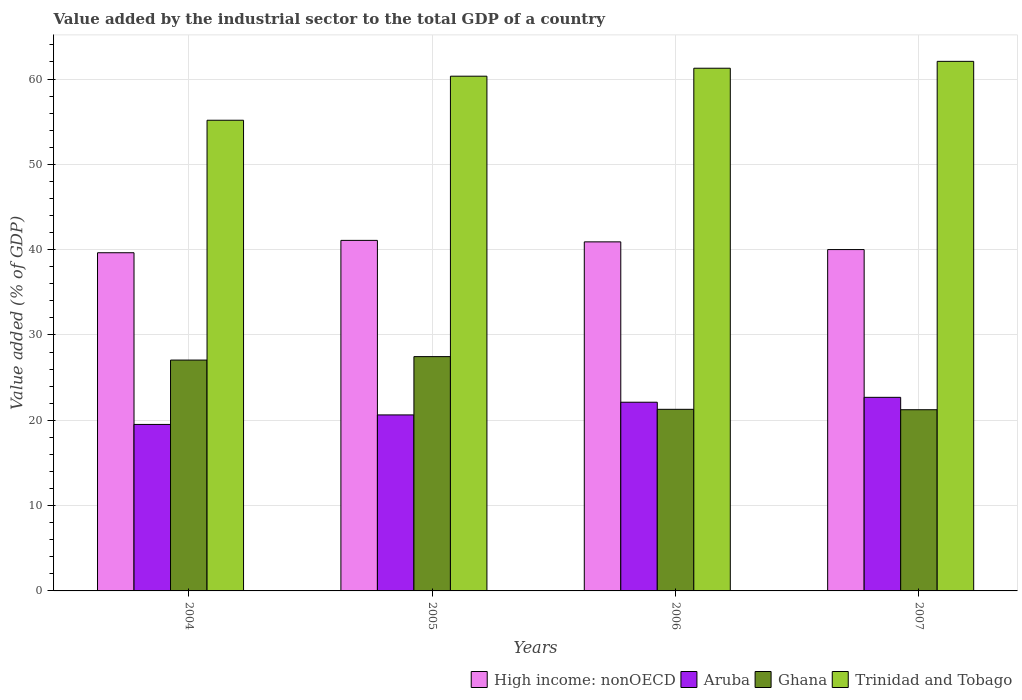How many different coloured bars are there?
Your response must be concise. 4. How many groups of bars are there?
Keep it short and to the point. 4. Are the number of bars on each tick of the X-axis equal?
Give a very brief answer. Yes. How many bars are there on the 3rd tick from the right?
Your answer should be compact. 4. In how many cases, is the number of bars for a given year not equal to the number of legend labels?
Your answer should be very brief. 0. What is the value added by the industrial sector to the total GDP in High income: nonOECD in 2005?
Provide a short and direct response. 41.09. Across all years, what is the maximum value added by the industrial sector to the total GDP in High income: nonOECD?
Keep it short and to the point. 41.09. Across all years, what is the minimum value added by the industrial sector to the total GDP in Trinidad and Tobago?
Provide a succinct answer. 55.17. In which year was the value added by the industrial sector to the total GDP in Aruba maximum?
Provide a short and direct response. 2007. What is the total value added by the industrial sector to the total GDP in Aruba in the graph?
Keep it short and to the point. 84.95. What is the difference between the value added by the industrial sector to the total GDP in Aruba in 2005 and that in 2007?
Provide a short and direct response. -2.06. What is the difference between the value added by the industrial sector to the total GDP in Trinidad and Tobago in 2005 and the value added by the industrial sector to the total GDP in Aruba in 2004?
Ensure brevity in your answer.  40.82. What is the average value added by the industrial sector to the total GDP in Trinidad and Tobago per year?
Ensure brevity in your answer.  59.71. In the year 2005, what is the difference between the value added by the industrial sector to the total GDP in Trinidad and Tobago and value added by the industrial sector to the total GDP in Ghana?
Your response must be concise. 32.87. What is the ratio of the value added by the industrial sector to the total GDP in High income: nonOECD in 2005 to that in 2007?
Keep it short and to the point. 1.03. Is the difference between the value added by the industrial sector to the total GDP in Trinidad and Tobago in 2006 and 2007 greater than the difference between the value added by the industrial sector to the total GDP in Ghana in 2006 and 2007?
Provide a succinct answer. No. What is the difference between the highest and the second highest value added by the industrial sector to the total GDP in Aruba?
Your response must be concise. 0.57. What is the difference between the highest and the lowest value added by the industrial sector to the total GDP in Aruba?
Give a very brief answer. 3.18. Is the sum of the value added by the industrial sector to the total GDP in Trinidad and Tobago in 2004 and 2006 greater than the maximum value added by the industrial sector to the total GDP in Ghana across all years?
Provide a succinct answer. Yes. Is it the case that in every year, the sum of the value added by the industrial sector to the total GDP in High income: nonOECD and value added by the industrial sector to the total GDP in Trinidad and Tobago is greater than the sum of value added by the industrial sector to the total GDP in Aruba and value added by the industrial sector to the total GDP in Ghana?
Give a very brief answer. Yes. What does the 4th bar from the left in 2004 represents?
Make the answer very short. Trinidad and Tobago. What does the 4th bar from the right in 2007 represents?
Your answer should be very brief. High income: nonOECD. Are all the bars in the graph horizontal?
Your answer should be very brief. No. What is the difference between two consecutive major ticks on the Y-axis?
Your answer should be very brief. 10. Does the graph contain grids?
Provide a succinct answer. Yes. Where does the legend appear in the graph?
Provide a short and direct response. Bottom right. What is the title of the graph?
Provide a short and direct response. Value added by the industrial sector to the total GDP of a country. Does "Fiji" appear as one of the legend labels in the graph?
Keep it short and to the point. No. What is the label or title of the X-axis?
Give a very brief answer. Years. What is the label or title of the Y-axis?
Your answer should be very brief. Value added (% of GDP). What is the Value added (% of GDP) of High income: nonOECD in 2004?
Your answer should be very brief. 39.64. What is the Value added (% of GDP) in Aruba in 2004?
Offer a very short reply. 19.51. What is the Value added (% of GDP) of Ghana in 2004?
Ensure brevity in your answer.  27.06. What is the Value added (% of GDP) of Trinidad and Tobago in 2004?
Your response must be concise. 55.17. What is the Value added (% of GDP) in High income: nonOECD in 2005?
Ensure brevity in your answer.  41.09. What is the Value added (% of GDP) of Aruba in 2005?
Your answer should be very brief. 20.63. What is the Value added (% of GDP) in Ghana in 2005?
Provide a short and direct response. 27.46. What is the Value added (% of GDP) of Trinidad and Tobago in 2005?
Provide a succinct answer. 60.33. What is the Value added (% of GDP) of High income: nonOECD in 2006?
Provide a short and direct response. 40.91. What is the Value added (% of GDP) of Aruba in 2006?
Provide a short and direct response. 22.12. What is the Value added (% of GDP) of Ghana in 2006?
Offer a very short reply. 21.29. What is the Value added (% of GDP) in Trinidad and Tobago in 2006?
Your answer should be compact. 61.26. What is the Value added (% of GDP) in High income: nonOECD in 2007?
Provide a succinct answer. 40.01. What is the Value added (% of GDP) in Aruba in 2007?
Offer a terse response. 22.69. What is the Value added (% of GDP) in Ghana in 2007?
Your answer should be very brief. 21.24. What is the Value added (% of GDP) of Trinidad and Tobago in 2007?
Offer a very short reply. 62.07. Across all years, what is the maximum Value added (% of GDP) in High income: nonOECD?
Your response must be concise. 41.09. Across all years, what is the maximum Value added (% of GDP) of Aruba?
Your response must be concise. 22.69. Across all years, what is the maximum Value added (% of GDP) in Ghana?
Offer a terse response. 27.46. Across all years, what is the maximum Value added (% of GDP) of Trinidad and Tobago?
Provide a succinct answer. 62.07. Across all years, what is the minimum Value added (% of GDP) of High income: nonOECD?
Give a very brief answer. 39.64. Across all years, what is the minimum Value added (% of GDP) of Aruba?
Give a very brief answer. 19.51. Across all years, what is the minimum Value added (% of GDP) in Ghana?
Your response must be concise. 21.24. Across all years, what is the minimum Value added (% of GDP) of Trinidad and Tobago?
Offer a terse response. 55.17. What is the total Value added (% of GDP) of High income: nonOECD in the graph?
Keep it short and to the point. 161.64. What is the total Value added (% of GDP) of Aruba in the graph?
Give a very brief answer. 84.95. What is the total Value added (% of GDP) in Ghana in the graph?
Give a very brief answer. 97.04. What is the total Value added (% of GDP) of Trinidad and Tobago in the graph?
Provide a succinct answer. 238.83. What is the difference between the Value added (% of GDP) of High income: nonOECD in 2004 and that in 2005?
Offer a terse response. -1.45. What is the difference between the Value added (% of GDP) of Aruba in 2004 and that in 2005?
Your response must be concise. -1.12. What is the difference between the Value added (% of GDP) in Ghana in 2004 and that in 2005?
Ensure brevity in your answer.  -0.4. What is the difference between the Value added (% of GDP) of Trinidad and Tobago in 2004 and that in 2005?
Make the answer very short. -5.16. What is the difference between the Value added (% of GDP) of High income: nonOECD in 2004 and that in 2006?
Keep it short and to the point. -1.27. What is the difference between the Value added (% of GDP) of Aruba in 2004 and that in 2006?
Provide a short and direct response. -2.6. What is the difference between the Value added (% of GDP) of Ghana in 2004 and that in 2006?
Give a very brief answer. 5.77. What is the difference between the Value added (% of GDP) in Trinidad and Tobago in 2004 and that in 2006?
Ensure brevity in your answer.  -6.1. What is the difference between the Value added (% of GDP) of High income: nonOECD in 2004 and that in 2007?
Your response must be concise. -0.37. What is the difference between the Value added (% of GDP) of Aruba in 2004 and that in 2007?
Provide a succinct answer. -3.18. What is the difference between the Value added (% of GDP) in Ghana in 2004 and that in 2007?
Your answer should be very brief. 5.82. What is the difference between the Value added (% of GDP) of Trinidad and Tobago in 2004 and that in 2007?
Provide a succinct answer. -6.9. What is the difference between the Value added (% of GDP) in High income: nonOECD in 2005 and that in 2006?
Provide a succinct answer. 0.17. What is the difference between the Value added (% of GDP) in Aruba in 2005 and that in 2006?
Keep it short and to the point. -1.49. What is the difference between the Value added (% of GDP) in Ghana in 2005 and that in 2006?
Make the answer very short. 6.18. What is the difference between the Value added (% of GDP) of Trinidad and Tobago in 2005 and that in 2006?
Your answer should be very brief. -0.93. What is the difference between the Value added (% of GDP) in High income: nonOECD in 2005 and that in 2007?
Your response must be concise. 1.08. What is the difference between the Value added (% of GDP) of Aruba in 2005 and that in 2007?
Keep it short and to the point. -2.06. What is the difference between the Value added (% of GDP) in Ghana in 2005 and that in 2007?
Provide a succinct answer. 6.22. What is the difference between the Value added (% of GDP) of Trinidad and Tobago in 2005 and that in 2007?
Provide a short and direct response. -1.74. What is the difference between the Value added (% of GDP) in High income: nonOECD in 2006 and that in 2007?
Give a very brief answer. 0.9. What is the difference between the Value added (% of GDP) in Aruba in 2006 and that in 2007?
Provide a succinct answer. -0.57. What is the difference between the Value added (% of GDP) in Ghana in 2006 and that in 2007?
Your response must be concise. 0.05. What is the difference between the Value added (% of GDP) of Trinidad and Tobago in 2006 and that in 2007?
Your answer should be compact. -0.81. What is the difference between the Value added (% of GDP) in High income: nonOECD in 2004 and the Value added (% of GDP) in Aruba in 2005?
Provide a short and direct response. 19.01. What is the difference between the Value added (% of GDP) of High income: nonOECD in 2004 and the Value added (% of GDP) of Ghana in 2005?
Provide a succinct answer. 12.18. What is the difference between the Value added (% of GDP) of High income: nonOECD in 2004 and the Value added (% of GDP) of Trinidad and Tobago in 2005?
Your answer should be very brief. -20.69. What is the difference between the Value added (% of GDP) in Aruba in 2004 and the Value added (% of GDP) in Ghana in 2005?
Keep it short and to the point. -7.95. What is the difference between the Value added (% of GDP) of Aruba in 2004 and the Value added (% of GDP) of Trinidad and Tobago in 2005?
Ensure brevity in your answer.  -40.82. What is the difference between the Value added (% of GDP) in Ghana in 2004 and the Value added (% of GDP) in Trinidad and Tobago in 2005?
Your answer should be compact. -33.27. What is the difference between the Value added (% of GDP) in High income: nonOECD in 2004 and the Value added (% of GDP) in Aruba in 2006?
Your answer should be compact. 17.52. What is the difference between the Value added (% of GDP) in High income: nonOECD in 2004 and the Value added (% of GDP) in Ghana in 2006?
Provide a succinct answer. 18.35. What is the difference between the Value added (% of GDP) of High income: nonOECD in 2004 and the Value added (% of GDP) of Trinidad and Tobago in 2006?
Keep it short and to the point. -21.63. What is the difference between the Value added (% of GDP) in Aruba in 2004 and the Value added (% of GDP) in Ghana in 2006?
Provide a succinct answer. -1.77. What is the difference between the Value added (% of GDP) in Aruba in 2004 and the Value added (% of GDP) in Trinidad and Tobago in 2006?
Ensure brevity in your answer.  -41.75. What is the difference between the Value added (% of GDP) in Ghana in 2004 and the Value added (% of GDP) in Trinidad and Tobago in 2006?
Your answer should be very brief. -34.21. What is the difference between the Value added (% of GDP) of High income: nonOECD in 2004 and the Value added (% of GDP) of Aruba in 2007?
Make the answer very short. 16.95. What is the difference between the Value added (% of GDP) in High income: nonOECD in 2004 and the Value added (% of GDP) in Ghana in 2007?
Your answer should be compact. 18.4. What is the difference between the Value added (% of GDP) of High income: nonOECD in 2004 and the Value added (% of GDP) of Trinidad and Tobago in 2007?
Your answer should be compact. -22.43. What is the difference between the Value added (% of GDP) of Aruba in 2004 and the Value added (% of GDP) of Ghana in 2007?
Your answer should be very brief. -1.72. What is the difference between the Value added (% of GDP) of Aruba in 2004 and the Value added (% of GDP) of Trinidad and Tobago in 2007?
Offer a very short reply. -42.56. What is the difference between the Value added (% of GDP) in Ghana in 2004 and the Value added (% of GDP) in Trinidad and Tobago in 2007?
Your response must be concise. -35.01. What is the difference between the Value added (% of GDP) in High income: nonOECD in 2005 and the Value added (% of GDP) in Aruba in 2006?
Your answer should be compact. 18.97. What is the difference between the Value added (% of GDP) in High income: nonOECD in 2005 and the Value added (% of GDP) in Ghana in 2006?
Ensure brevity in your answer.  19.8. What is the difference between the Value added (% of GDP) in High income: nonOECD in 2005 and the Value added (% of GDP) in Trinidad and Tobago in 2006?
Your answer should be very brief. -20.18. What is the difference between the Value added (% of GDP) in Aruba in 2005 and the Value added (% of GDP) in Ghana in 2006?
Your answer should be compact. -0.66. What is the difference between the Value added (% of GDP) in Aruba in 2005 and the Value added (% of GDP) in Trinidad and Tobago in 2006?
Your answer should be compact. -40.63. What is the difference between the Value added (% of GDP) in Ghana in 2005 and the Value added (% of GDP) in Trinidad and Tobago in 2006?
Your answer should be very brief. -33.8. What is the difference between the Value added (% of GDP) of High income: nonOECD in 2005 and the Value added (% of GDP) of Aruba in 2007?
Your answer should be very brief. 18.4. What is the difference between the Value added (% of GDP) in High income: nonOECD in 2005 and the Value added (% of GDP) in Ghana in 2007?
Offer a terse response. 19.85. What is the difference between the Value added (% of GDP) in High income: nonOECD in 2005 and the Value added (% of GDP) in Trinidad and Tobago in 2007?
Provide a succinct answer. -20.98. What is the difference between the Value added (% of GDP) of Aruba in 2005 and the Value added (% of GDP) of Ghana in 2007?
Give a very brief answer. -0.61. What is the difference between the Value added (% of GDP) in Aruba in 2005 and the Value added (% of GDP) in Trinidad and Tobago in 2007?
Provide a short and direct response. -41.44. What is the difference between the Value added (% of GDP) in Ghana in 2005 and the Value added (% of GDP) in Trinidad and Tobago in 2007?
Offer a terse response. -34.61. What is the difference between the Value added (% of GDP) in High income: nonOECD in 2006 and the Value added (% of GDP) in Aruba in 2007?
Ensure brevity in your answer.  18.22. What is the difference between the Value added (% of GDP) of High income: nonOECD in 2006 and the Value added (% of GDP) of Ghana in 2007?
Make the answer very short. 19.67. What is the difference between the Value added (% of GDP) of High income: nonOECD in 2006 and the Value added (% of GDP) of Trinidad and Tobago in 2007?
Offer a very short reply. -21.16. What is the difference between the Value added (% of GDP) of Aruba in 2006 and the Value added (% of GDP) of Ghana in 2007?
Your answer should be very brief. 0.88. What is the difference between the Value added (% of GDP) in Aruba in 2006 and the Value added (% of GDP) in Trinidad and Tobago in 2007?
Your answer should be compact. -39.95. What is the difference between the Value added (% of GDP) of Ghana in 2006 and the Value added (% of GDP) of Trinidad and Tobago in 2007?
Offer a very short reply. -40.78. What is the average Value added (% of GDP) of High income: nonOECD per year?
Keep it short and to the point. 40.41. What is the average Value added (% of GDP) of Aruba per year?
Keep it short and to the point. 21.24. What is the average Value added (% of GDP) in Ghana per year?
Offer a terse response. 24.26. What is the average Value added (% of GDP) of Trinidad and Tobago per year?
Make the answer very short. 59.71. In the year 2004, what is the difference between the Value added (% of GDP) in High income: nonOECD and Value added (% of GDP) in Aruba?
Offer a terse response. 20.12. In the year 2004, what is the difference between the Value added (% of GDP) in High income: nonOECD and Value added (% of GDP) in Ghana?
Your answer should be very brief. 12.58. In the year 2004, what is the difference between the Value added (% of GDP) of High income: nonOECD and Value added (% of GDP) of Trinidad and Tobago?
Offer a terse response. -15.53. In the year 2004, what is the difference between the Value added (% of GDP) in Aruba and Value added (% of GDP) in Ghana?
Offer a terse response. -7.54. In the year 2004, what is the difference between the Value added (% of GDP) of Aruba and Value added (% of GDP) of Trinidad and Tobago?
Offer a very short reply. -35.65. In the year 2004, what is the difference between the Value added (% of GDP) in Ghana and Value added (% of GDP) in Trinidad and Tobago?
Offer a very short reply. -28.11. In the year 2005, what is the difference between the Value added (% of GDP) of High income: nonOECD and Value added (% of GDP) of Aruba?
Ensure brevity in your answer.  20.46. In the year 2005, what is the difference between the Value added (% of GDP) in High income: nonOECD and Value added (% of GDP) in Ghana?
Your answer should be very brief. 13.62. In the year 2005, what is the difference between the Value added (% of GDP) of High income: nonOECD and Value added (% of GDP) of Trinidad and Tobago?
Your answer should be compact. -19.24. In the year 2005, what is the difference between the Value added (% of GDP) in Aruba and Value added (% of GDP) in Ghana?
Keep it short and to the point. -6.83. In the year 2005, what is the difference between the Value added (% of GDP) in Aruba and Value added (% of GDP) in Trinidad and Tobago?
Keep it short and to the point. -39.7. In the year 2005, what is the difference between the Value added (% of GDP) in Ghana and Value added (% of GDP) in Trinidad and Tobago?
Ensure brevity in your answer.  -32.87. In the year 2006, what is the difference between the Value added (% of GDP) in High income: nonOECD and Value added (% of GDP) in Aruba?
Offer a terse response. 18.8. In the year 2006, what is the difference between the Value added (% of GDP) of High income: nonOECD and Value added (% of GDP) of Ghana?
Your response must be concise. 19.63. In the year 2006, what is the difference between the Value added (% of GDP) in High income: nonOECD and Value added (% of GDP) in Trinidad and Tobago?
Give a very brief answer. -20.35. In the year 2006, what is the difference between the Value added (% of GDP) of Aruba and Value added (% of GDP) of Ghana?
Your response must be concise. 0.83. In the year 2006, what is the difference between the Value added (% of GDP) of Aruba and Value added (% of GDP) of Trinidad and Tobago?
Keep it short and to the point. -39.15. In the year 2006, what is the difference between the Value added (% of GDP) in Ghana and Value added (% of GDP) in Trinidad and Tobago?
Your answer should be very brief. -39.98. In the year 2007, what is the difference between the Value added (% of GDP) of High income: nonOECD and Value added (% of GDP) of Aruba?
Your answer should be compact. 17.32. In the year 2007, what is the difference between the Value added (% of GDP) of High income: nonOECD and Value added (% of GDP) of Ghana?
Your response must be concise. 18.77. In the year 2007, what is the difference between the Value added (% of GDP) in High income: nonOECD and Value added (% of GDP) in Trinidad and Tobago?
Your answer should be very brief. -22.06. In the year 2007, what is the difference between the Value added (% of GDP) in Aruba and Value added (% of GDP) in Ghana?
Give a very brief answer. 1.45. In the year 2007, what is the difference between the Value added (% of GDP) in Aruba and Value added (% of GDP) in Trinidad and Tobago?
Provide a succinct answer. -39.38. In the year 2007, what is the difference between the Value added (% of GDP) of Ghana and Value added (% of GDP) of Trinidad and Tobago?
Ensure brevity in your answer.  -40.83. What is the ratio of the Value added (% of GDP) in High income: nonOECD in 2004 to that in 2005?
Ensure brevity in your answer.  0.96. What is the ratio of the Value added (% of GDP) in Aruba in 2004 to that in 2005?
Offer a terse response. 0.95. What is the ratio of the Value added (% of GDP) of Trinidad and Tobago in 2004 to that in 2005?
Provide a succinct answer. 0.91. What is the ratio of the Value added (% of GDP) of High income: nonOECD in 2004 to that in 2006?
Offer a terse response. 0.97. What is the ratio of the Value added (% of GDP) in Aruba in 2004 to that in 2006?
Your answer should be very brief. 0.88. What is the ratio of the Value added (% of GDP) in Ghana in 2004 to that in 2006?
Provide a short and direct response. 1.27. What is the ratio of the Value added (% of GDP) of Trinidad and Tobago in 2004 to that in 2006?
Give a very brief answer. 0.9. What is the ratio of the Value added (% of GDP) of Aruba in 2004 to that in 2007?
Offer a very short reply. 0.86. What is the ratio of the Value added (% of GDP) of Ghana in 2004 to that in 2007?
Provide a succinct answer. 1.27. What is the ratio of the Value added (% of GDP) of Trinidad and Tobago in 2004 to that in 2007?
Your answer should be very brief. 0.89. What is the ratio of the Value added (% of GDP) in High income: nonOECD in 2005 to that in 2006?
Make the answer very short. 1. What is the ratio of the Value added (% of GDP) of Aruba in 2005 to that in 2006?
Give a very brief answer. 0.93. What is the ratio of the Value added (% of GDP) in Ghana in 2005 to that in 2006?
Make the answer very short. 1.29. What is the ratio of the Value added (% of GDP) of Trinidad and Tobago in 2005 to that in 2006?
Your answer should be very brief. 0.98. What is the ratio of the Value added (% of GDP) of High income: nonOECD in 2005 to that in 2007?
Your answer should be very brief. 1.03. What is the ratio of the Value added (% of GDP) of Aruba in 2005 to that in 2007?
Give a very brief answer. 0.91. What is the ratio of the Value added (% of GDP) of Ghana in 2005 to that in 2007?
Your answer should be very brief. 1.29. What is the ratio of the Value added (% of GDP) of Trinidad and Tobago in 2005 to that in 2007?
Ensure brevity in your answer.  0.97. What is the ratio of the Value added (% of GDP) in High income: nonOECD in 2006 to that in 2007?
Offer a very short reply. 1.02. What is the ratio of the Value added (% of GDP) of Aruba in 2006 to that in 2007?
Your answer should be compact. 0.97. What is the ratio of the Value added (% of GDP) of Ghana in 2006 to that in 2007?
Make the answer very short. 1. What is the difference between the highest and the second highest Value added (% of GDP) in High income: nonOECD?
Your answer should be very brief. 0.17. What is the difference between the highest and the second highest Value added (% of GDP) in Aruba?
Ensure brevity in your answer.  0.57. What is the difference between the highest and the second highest Value added (% of GDP) of Ghana?
Make the answer very short. 0.4. What is the difference between the highest and the second highest Value added (% of GDP) in Trinidad and Tobago?
Ensure brevity in your answer.  0.81. What is the difference between the highest and the lowest Value added (% of GDP) in High income: nonOECD?
Ensure brevity in your answer.  1.45. What is the difference between the highest and the lowest Value added (% of GDP) of Aruba?
Ensure brevity in your answer.  3.18. What is the difference between the highest and the lowest Value added (% of GDP) of Ghana?
Your answer should be compact. 6.22. What is the difference between the highest and the lowest Value added (% of GDP) of Trinidad and Tobago?
Your answer should be very brief. 6.9. 